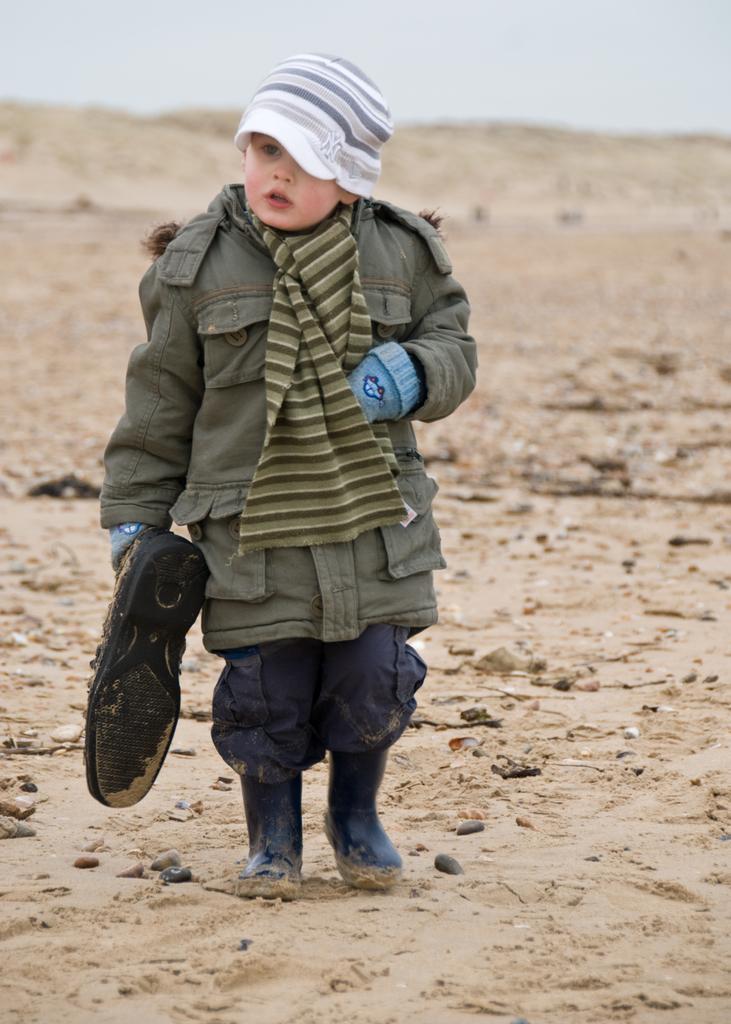Could you give a brief overview of what you see in this image? In the picture we can see a child standing on the sand surface and child is wearing a jacket and holding a shoe in the hand and also wearing a cap, which is white in color with some lines on it and in the background we can see a hill and sky. 